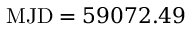<formula> <loc_0><loc_0><loc_500><loc_500>M J D = 5 9 0 7 2 . 4 9</formula> 